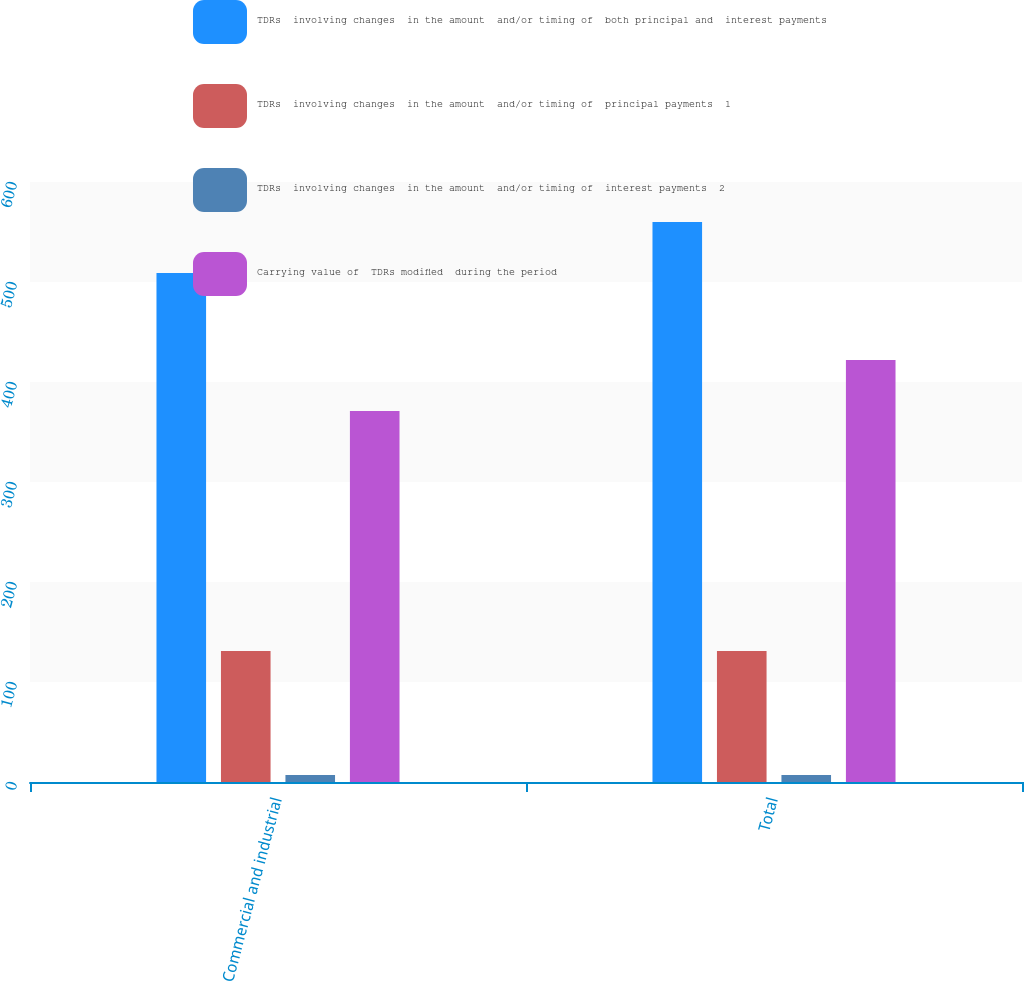<chart> <loc_0><loc_0><loc_500><loc_500><stacked_bar_chart><ecel><fcel>Commercial and industrial<fcel>Total<nl><fcel>TDRs  involving changes  in the amount  and/or timing of  both principal and  interest payments<fcel>509<fcel>560<nl><fcel>TDRs  involving changes  in the amount  and/or timing of  principal payments  1<fcel>131<fcel>131<nl><fcel>TDRs  involving changes  in the amount  and/or timing of  interest payments  2<fcel>7<fcel>7<nl><fcel>Carrying value of  TDRs modified  during the period<fcel>371<fcel>422<nl></chart> 